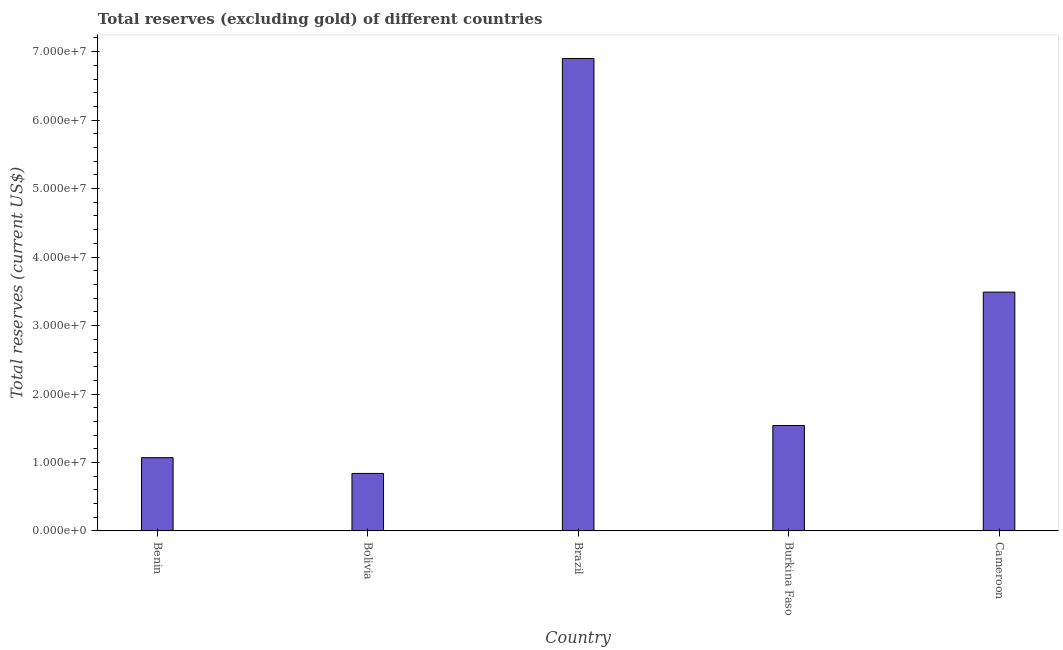Does the graph contain any zero values?
Provide a short and direct response. No. What is the title of the graph?
Make the answer very short. Total reserves (excluding gold) of different countries. What is the label or title of the X-axis?
Ensure brevity in your answer.  Country. What is the label or title of the Y-axis?
Offer a terse response. Total reserves (current US$). What is the total reserves (excluding gold) in Burkina Faso?
Give a very brief answer. 1.54e+07. Across all countries, what is the maximum total reserves (excluding gold)?
Give a very brief answer. 6.90e+07. Across all countries, what is the minimum total reserves (excluding gold)?
Provide a succinct answer. 8.40e+06. In which country was the total reserves (excluding gold) maximum?
Ensure brevity in your answer.  Brazil. What is the sum of the total reserves (excluding gold)?
Offer a terse response. 1.38e+08. What is the difference between the total reserves (excluding gold) in Brazil and Burkina Faso?
Provide a short and direct response. 5.36e+07. What is the average total reserves (excluding gold) per country?
Offer a terse response. 2.77e+07. What is the median total reserves (excluding gold)?
Give a very brief answer. 1.54e+07. What is the ratio of the total reserves (excluding gold) in Bolivia to that in Burkina Faso?
Your answer should be very brief. 0.55. What is the difference between the highest and the second highest total reserves (excluding gold)?
Your answer should be compact. 3.41e+07. What is the difference between the highest and the lowest total reserves (excluding gold)?
Give a very brief answer. 6.06e+07. How many bars are there?
Keep it short and to the point. 5. Are all the bars in the graph horizontal?
Ensure brevity in your answer.  No. Are the values on the major ticks of Y-axis written in scientific E-notation?
Offer a terse response. Yes. What is the Total reserves (current US$) in Benin?
Make the answer very short. 1.07e+07. What is the Total reserves (current US$) in Bolivia?
Keep it short and to the point. 8.40e+06. What is the Total reserves (current US$) in Brazil?
Give a very brief answer. 6.90e+07. What is the Total reserves (current US$) of Burkina Faso?
Provide a succinct answer. 1.54e+07. What is the Total reserves (current US$) of Cameroon?
Offer a very short reply. 3.49e+07. What is the difference between the Total reserves (current US$) in Benin and Bolivia?
Provide a short and direct response. 2.30e+06. What is the difference between the Total reserves (current US$) in Benin and Brazil?
Keep it short and to the point. -5.83e+07. What is the difference between the Total reserves (current US$) in Benin and Burkina Faso?
Offer a very short reply. -4.70e+06. What is the difference between the Total reserves (current US$) in Benin and Cameroon?
Offer a terse response. -2.42e+07. What is the difference between the Total reserves (current US$) in Bolivia and Brazil?
Provide a succinct answer. -6.06e+07. What is the difference between the Total reserves (current US$) in Bolivia and Burkina Faso?
Ensure brevity in your answer.  -7.00e+06. What is the difference between the Total reserves (current US$) in Bolivia and Cameroon?
Make the answer very short. -2.65e+07. What is the difference between the Total reserves (current US$) in Brazil and Burkina Faso?
Your answer should be compact. 5.36e+07. What is the difference between the Total reserves (current US$) in Brazil and Cameroon?
Provide a short and direct response. 3.41e+07. What is the difference between the Total reserves (current US$) in Burkina Faso and Cameroon?
Your answer should be compact. -1.95e+07. What is the ratio of the Total reserves (current US$) in Benin to that in Bolivia?
Your answer should be very brief. 1.27. What is the ratio of the Total reserves (current US$) in Benin to that in Brazil?
Your response must be concise. 0.15. What is the ratio of the Total reserves (current US$) in Benin to that in Burkina Faso?
Keep it short and to the point. 0.69. What is the ratio of the Total reserves (current US$) in Benin to that in Cameroon?
Give a very brief answer. 0.31. What is the ratio of the Total reserves (current US$) in Bolivia to that in Brazil?
Give a very brief answer. 0.12. What is the ratio of the Total reserves (current US$) in Bolivia to that in Burkina Faso?
Your answer should be compact. 0.55. What is the ratio of the Total reserves (current US$) in Bolivia to that in Cameroon?
Ensure brevity in your answer.  0.24. What is the ratio of the Total reserves (current US$) in Brazil to that in Burkina Faso?
Make the answer very short. 4.48. What is the ratio of the Total reserves (current US$) in Brazil to that in Cameroon?
Give a very brief answer. 1.98. What is the ratio of the Total reserves (current US$) in Burkina Faso to that in Cameroon?
Make the answer very short. 0.44. 